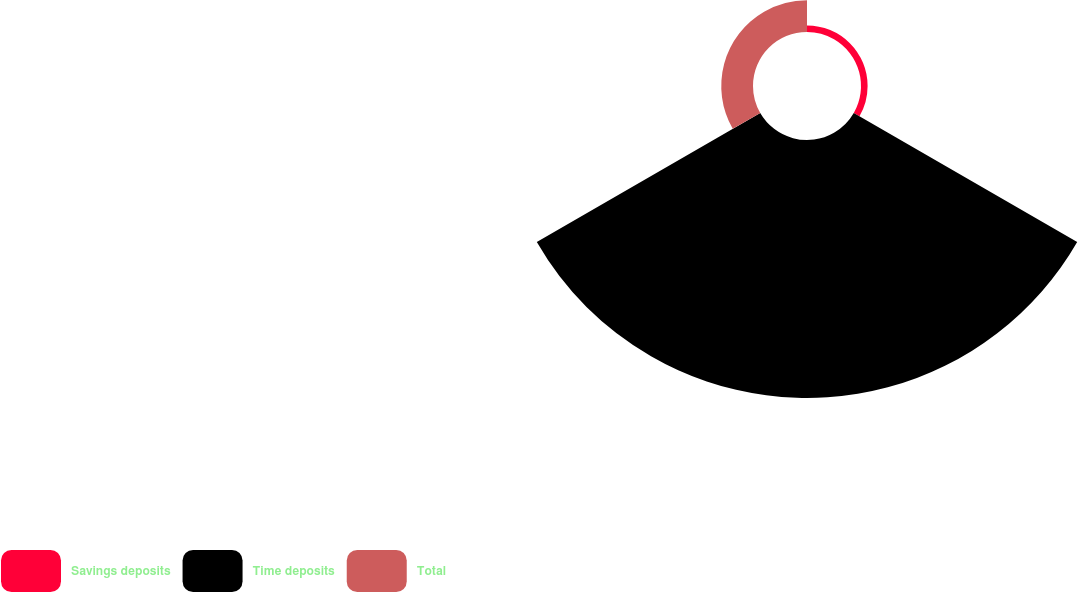Convert chart to OTSL. <chart><loc_0><loc_0><loc_500><loc_500><pie_chart><fcel>Savings deposits<fcel>Time deposits<fcel>Total<nl><fcel>2.23%<fcel>87.05%<fcel>10.71%<nl></chart> 